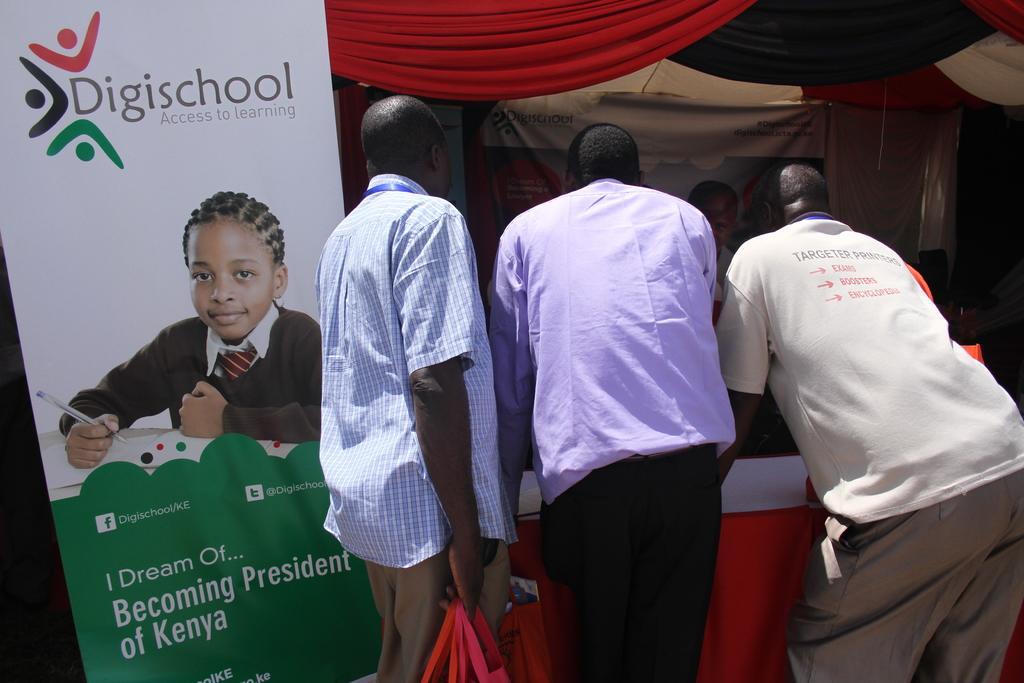Please provide a concise description of this image. In this image there are three men standing, there is a man holding an object, there is a table towards the bottom of the image, there is a cloth on the table, there are clothes towards the top of the image, there is a banner, there is text on the banner, there is a board towards the left of the image, there is text on the board, there is a girl on the board, she is holding a pen, there is a book on the board, there is a table on the board. 